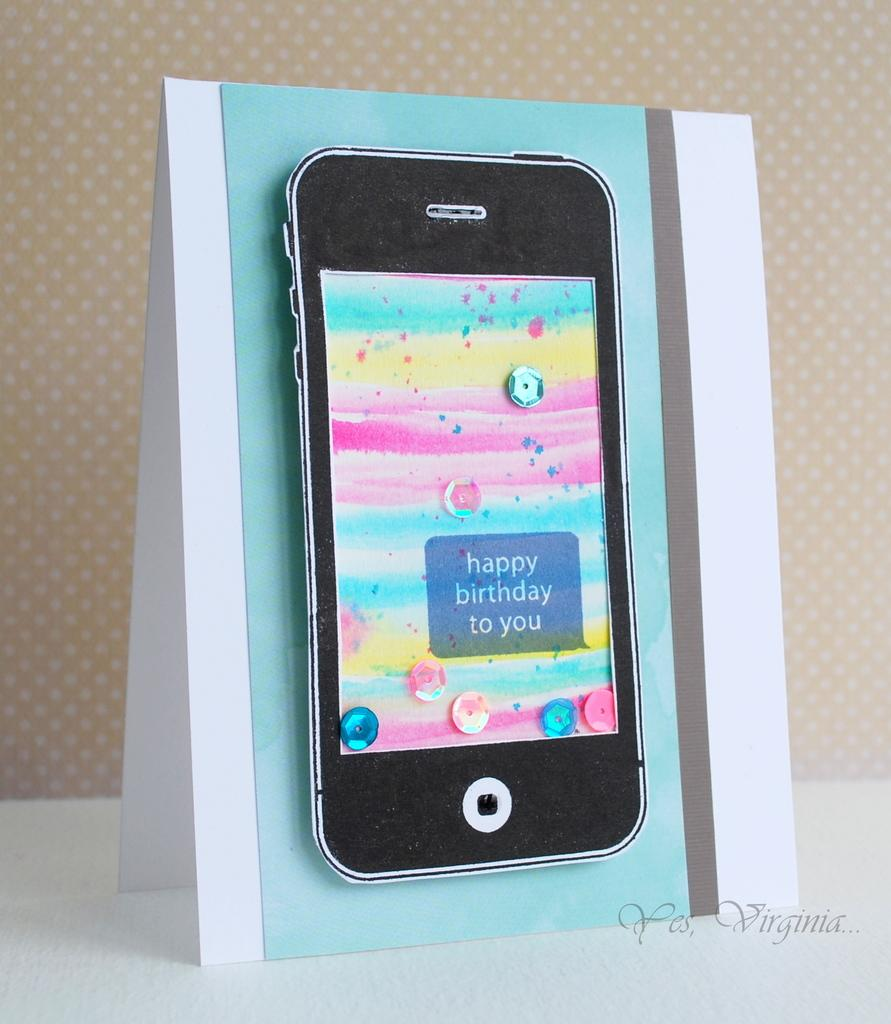<image>
Share a concise interpretation of the image provided. A black phone shows a happy birthday message on its screen. 